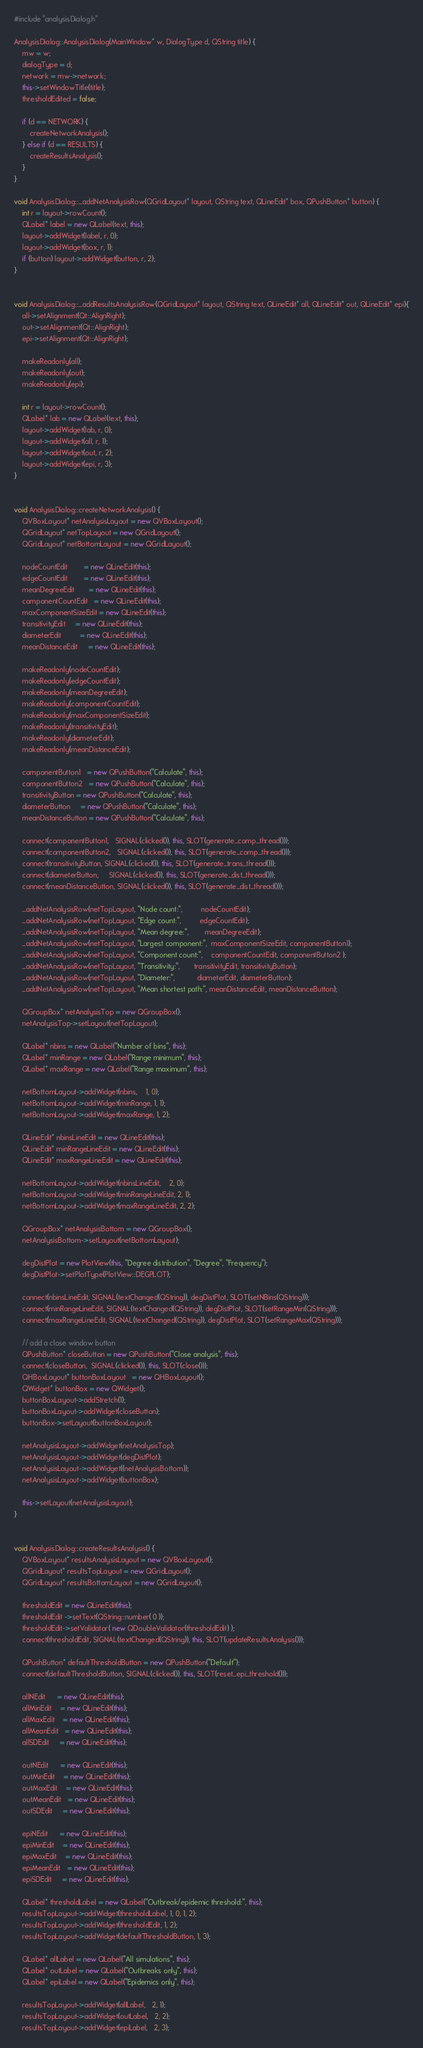Convert code to text. <code><loc_0><loc_0><loc_500><loc_500><_C++_>#include "analysisDialog.h"

AnalysisDialog::AnalysisDialog(MainWindow* w, DialogType d, QString title) {
    mw = w;
    dialogType = d;
    network = mw->network;
    this->setWindowTitle(title);
    thresholdEdited = false;
    
    if (d == NETWORK) {
        createNetworkAnalysis();
    } else if (d == RESULTS) {
        createResultsAnalysis();
    }
}

void AnalysisDialog::_addNetAnalysisRow(QGridLayout* layout, QString text, QLineEdit* box, QPushButton* button) {
    int r = layout->rowCount();
    QLabel* label = new QLabel(text, this);
    layout->addWidget(label, r, 0);
    layout->addWidget(box, r, 1);
    if (button) layout->addWidget(button, r, 2);
}


void AnalysisDialog::_addResultsAnalysisRow(QGridLayout* layout, QString text, QLineEdit* all, QLineEdit* out, QLineEdit* epi){
    all->setAlignment(Qt::AlignRight);
    out->setAlignment(Qt::AlignRight);
    epi->setAlignment(Qt::AlignRight);

    makeReadonly(all);
    makeReadonly(out);
    makeReadonly(epi);

    int r = layout->rowCount();
    QLabel* lab = new QLabel(text, this);
    layout->addWidget(lab, r, 0);
    layout->addWidget(all, r, 1);
    layout->addWidget(out, r, 2);
    layout->addWidget(epi, r, 3);
}


void AnalysisDialog::createNetworkAnalysis() {
    QVBoxLayout* netAnalysisLayout = new QVBoxLayout();
    QGridLayout* netTopLayout = new QGridLayout();
    QGridLayout* netBottomLayout = new QGridLayout();

    nodeCountEdit        = new QLineEdit(this);
    edgeCountEdit        = new QLineEdit(this);
    meanDegreeEdit       = new QLineEdit(this);
    componentCountEdit   = new QLineEdit(this);
    maxComponentSizeEdit = new QLineEdit(this);
    transitivityEdit     = new QLineEdit(this);
    diameterEdit         = new QLineEdit(this);
    meanDistanceEdit     = new QLineEdit(this);

    makeReadonly(nodeCountEdit);
    makeReadonly(edgeCountEdit);
    makeReadonly(meanDegreeEdit);
    makeReadonly(componentCountEdit);
    makeReadonly(maxComponentSizeEdit);
    makeReadonly(transitivityEdit);
    makeReadonly(diameterEdit);
    makeReadonly(meanDistanceEdit);

    componentButton1   = new QPushButton("Calculate", this);
    componentButton2   = new QPushButton("Calculate", this);
    transitivityButton = new QPushButton("Calculate", this);
    diameterButton     = new QPushButton("Calculate", this);
    meanDistanceButton = new QPushButton("Calculate", this);

    connect(componentButton1,   SIGNAL(clicked()), this, SLOT(generate_comp_thread()));
    connect(componentButton2,   SIGNAL(clicked()), this, SLOT(generate_comp_thread()));
    connect(transitivityButton, SIGNAL(clicked()), this, SLOT(generate_trans_thread()));
    connect(diameterButton,     SIGNAL(clicked()), this, SLOT(generate_dist_thread()));
    connect(meanDistanceButton, SIGNAL(clicked()), this, SLOT(generate_dist_thread()));

    _addNetAnalysisRow(netTopLayout, "Node count:",         nodeCountEdit);
    _addNetAnalysisRow(netTopLayout, "Edge count:",         edgeCountEdit);
    _addNetAnalysisRow(netTopLayout, "Mean degree:",        meanDegreeEdit);
    _addNetAnalysisRow(netTopLayout, "Largest component:",  maxComponentSizeEdit, componentButton1);
    _addNetAnalysisRow(netTopLayout, "Component count:",    componentCountEdit, componentButton2 );
    _addNetAnalysisRow(netTopLayout, "Transitivity:",       transitivityEdit, transitivityButton);
    _addNetAnalysisRow(netTopLayout, "Diameter:",           diameterEdit, diameterButton);
    _addNetAnalysisRow(netTopLayout, "Mean shortest path:", meanDistanceEdit, meanDistanceButton);

    QGroupBox* netAnalysisTop = new QGroupBox();
    netAnalysisTop->setLayout(netTopLayout);

    QLabel* nbins = new QLabel("Number of bins", this);
    QLabel* minRange = new QLabel("Range minimum", this);
    QLabel* maxRange = new QLabel("Range maximum", this);

    netBottomLayout->addWidget(nbins,    1, 0);
    netBottomLayout->addWidget(minRange, 1, 1);
    netBottomLayout->addWidget(maxRange, 1, 2);

    QLineEdit* nbinsLineEdit = new QLineEdit(this);
    QLineEdit* minRangeLineEdit = new QLineEdit(this);
    QLineEdit* maxRangeLineEdit = new QLineEdit(this);

    netBottomLayout->addWidget(nbinsLineEdit,    2, 0);
    netBottomLayout->addWidget(minRangeLineEdit, 2, 1);
    netBottomLayout->addWidget(maxRangeLineEdit, 2, 2);

    QGroupBox* netAnalysisBottom = new QGroupBox();
    netAnalysisBottom->setLayout(netBottomLayout);

    degDistPlot = new PlotView(this, "Degree distribution", "Degree", "Frequency");
    degDistPlot->setPlotType(PlotView::DEGPLOT);
    
    connect(nbinsLineEdit, SIGNAL(textChanged(QString)), degDistPlot, SLOT(setNBins(QString)));
    connect(minRangeLineEdit, SIGNAL(textChanged(QString)), degDistPlot, SLOT(setRangeMin(QString)));
    connect(maxRangeLineEdit, SIGNAL(textChanged(QString)), degDistPlot, SLOT(setRangeMax(QString)));

    // add a close window button
    QPushButton* closeButton = new QPushButton("Close analysis", this);
    connect(closeButton,  SIGNAL(clicked()), this, SLOT(close()));
    QHBoxLayout* buttonBoxLayout   = new QHBoxLayout();
    QWidget* buttonBox = new QWidget();
    buttonBoxLayout->addStretch(1);
    buttonBoxLayout->addWidget(closeButton);
    buttonBox->setLayout(buttonBoxLayout);

    netAnalysisLayout->addWidget(netAnalysisTop);
    netAnalysisLayout->addWidget(degDistPlot);
    netAnalysisLayout->addWidget((netAnalysisBottom));
    netAnalysisLayout->addWidget(buttonBox);
    
    this->setLayout(netAnalysisLayout);
}


void AnalysisDialog::createResultsAnalysis() {
    QVBoxLayout* resultsAnalysisLayout = new QVBoxLayout();
    QGridLayout* resultsTopLayout = new QGridLayout();
    QGridLayout* resultsBottomLayout = new QGridLayout();

    thresholdEdit = new QLineEdit(this);
    thresholdEdit ->setText(QString::number( 0 ));
    thresholdEdit->setValidator( new QDoubleValidator(thresholdEdit) );
    connect(thresholdEdit, SIGNAL(textChanged(QString)), this, SLOT(updateResultsAnalysis()));

    QPushButton* defaultThresholdButton = new QPushButton("Default");
    connect(defaultThresholdButton, SIGNAL(clicked()), this, SLOT(reset_epi_threshold()));

    allNEdit      = new QLineEdit(this);
    allMinEdit    = new QLineEdit(this);
    allMaxEdit    = new QLineEdit(this);
    allMeanEdit   = new QLineEdit(this);
    allSDEdit     = new QLineEdit(this);

    outNEdit      = new QLineEdit(this);
    outMinEdit    = new QLineEdit(this);
    outMaxEdit    = new QLineEdit(this);
    outMeanEdit   = new QLineEdit(this);
    outSDEdit     = new QLineEdit(this);

    epiNEdit      = new QLineEdit(this);
    epiMinEdit    = new QLineEdit(this);
    epiMaxEdit    = new QLineEdit(this);
    epiMeanEdit   = new QLineEdit(this);
    epiSDEdit     = new QLineEdit(this);
     
    QLabel* thresholdLabel = new QLabel("Outbreak/epidemic threshold:", this);
    resultsTopLayout->addWidget(thresholdLabel, 1, 0, 1, 2); 
    resultsTopLayout->addWidget(thresholdEdit, 1, 2); 
    resultsTopLayout->addWidget(defaultThresholdButton, 1, 3); 

    QLabel* allLabel = new QLabel("All simulations", this);
    QLabel* outLabel = new QLabel("Outbreaks only", this);
    QLabel* epiLabel = new QLabel("Epidemics only", this);

    resultsTopLayout->addWidget(allLabel,   2, 1);
    resultsTopLayout->addWidget(outLabel,   2, 2);
    resultsTopLayout->addWidget(epiLabel,   2, 3);
</code> 